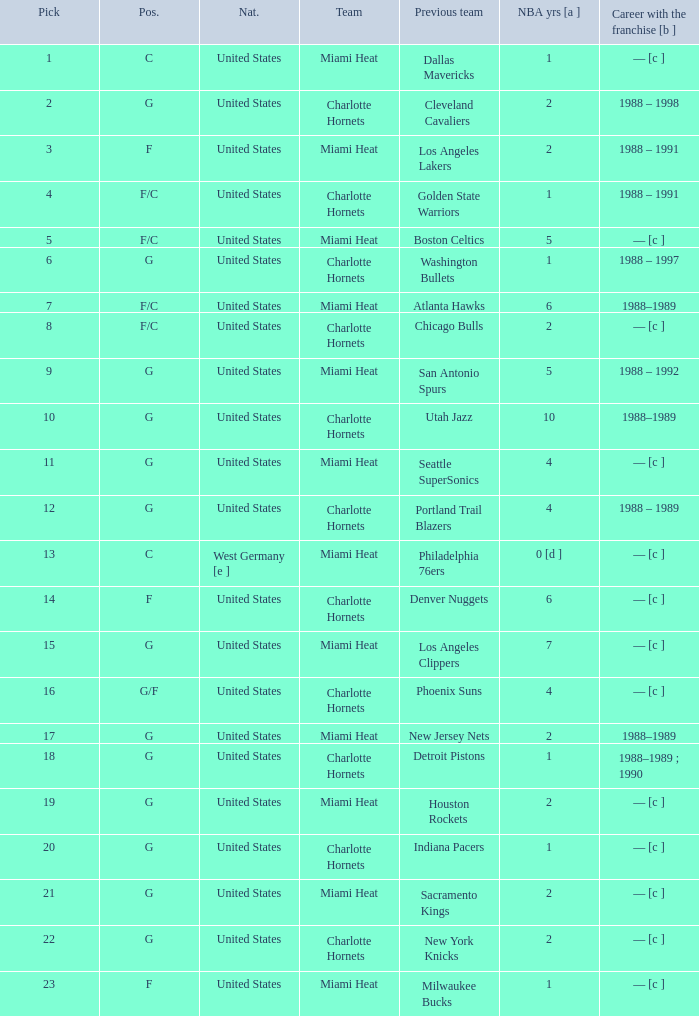What is the previous team of the player with 4 NBA years and a pick less than 16? Seattle SuperSonics, Portland Trail Blazers. 